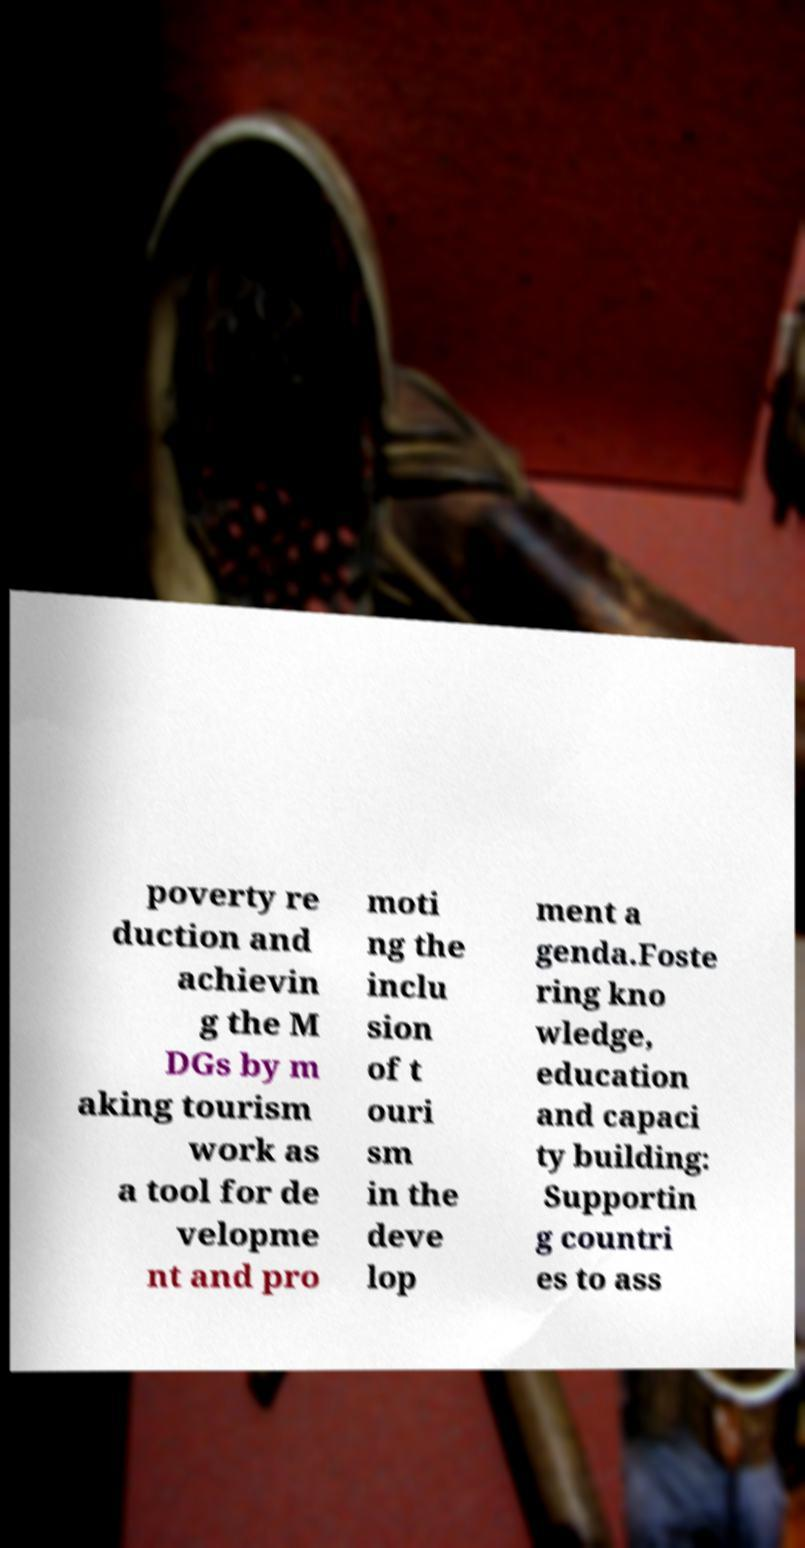Can you accurately transcribe the text from the provided image for me? poverty re duction and achievin g the M DGs by m aking tourism work as a tool for de velopme nt and pro moti ng the inclu sion of t ouri sm in the deve lop ment a genda.Foste ring kno wledge, education and capaci ty building: Supportin g countri es to ass 